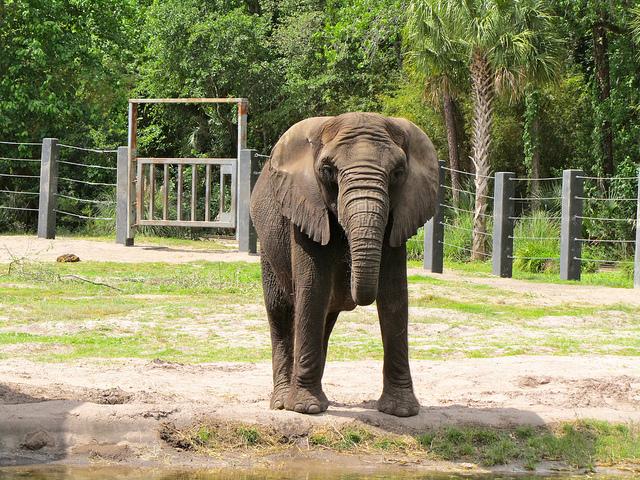Is the elephant in the wild?
Keep it brief. No. Is this an African elephant?
Be succinct. Yes. Is the animal wild?
Short answer required. No. What animal is this?
Be succinct. Elephant. Is the elephant in a zoo?
Give a very brief answer. Yes. How many animals are pictured?
Give a very brief answer. 1. Is this a large elephant?
Answer briefly. Yes. What is wrong with the elephant?
Be succinct. Nothing. 